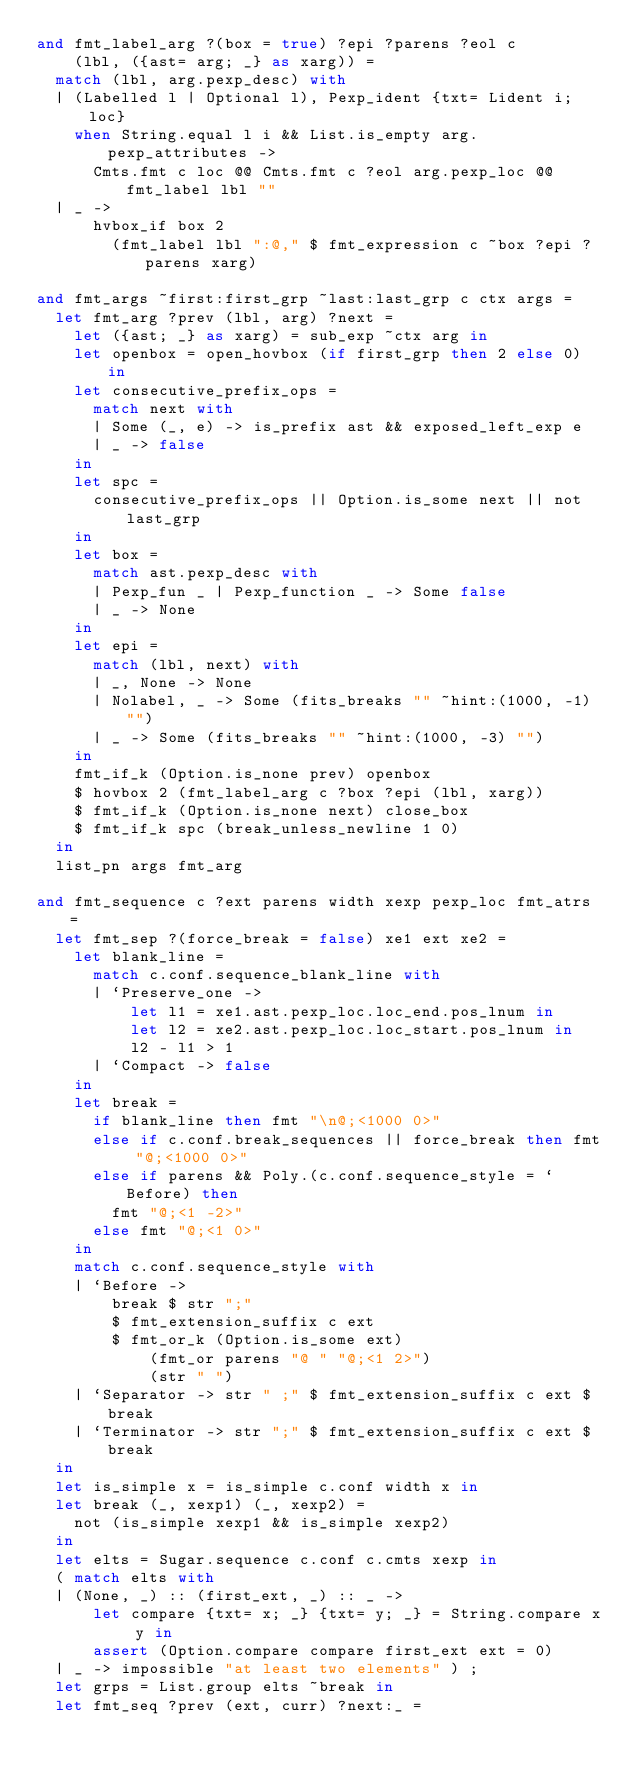<code> <loc_0><loc_0><loc_500><loc_500><_OCaml_>and fmt_label_arg ?(box = true) ?epi ?parens ?eol c
    (lbl, ({ast= arg; _} as xarg)) =
  match (lbl, arg.pexp_desc) with
  | (Labelled l | Optional l), Pexp_ident {txt= Lident i; loc}
    when String.equal l i && List.is_empty arg.pexp_attributes ->
      Cmts.fmt c loc @@ Cmts.fmt c ?eol arg.pexp_loc @@ fmt_label lbl ""
  | _ ->
      hvbox_if box 2
        (fmt_label lbl ":@," $ fmt_expression c ~box ?epi ?parens xarg)

and fmt_args ~first:first_grp ~last:last_grp c ctx args =
  let fmt_arg ?prev (lbl, arg) ?next =
    let ({ast; _} as xarg) = sub_exp ~ctx arg in
    let openbox = open_hovbox (if first_grp then 2 else 0) in
    let consecutive_prefix_ops =
      match next with
      | Some (_, e) -> is_prefix ast && exposed_left_exp e
      | _ -> false
    in
    let spc =
      consecutive_prefix_ops || Option.is_some next || not last_grp
    in
    let box =
      match ast.pexp_desc with
      | Pexp_fun _ | Pexp_function _ -> Some false
      | _ -> None
    in
    let epi =
      match (lbl, next) with
      | _, None -> None
      | Nolabel, _ -> Some (fits_breaks "" ~hint:(1000, -1) "")
      | _ -> Some (fits_breaks "" ~hint:(1000, -3) "")
    in
    fmt_if_k (Option.is_none prev) openbox
    $ hovbox 2 (fmt_label_arg c ?box ?epi (lbl, xarg))
    $ fmt_if_k (Option.is_none next) close_box
    $ fmt_if_k spc (break_unless_newline 1 0)
  in
  list_pn args fmt_arg

and fmt_sequence c ?ext parens width xexp pexp_loc fmt_atrs =
  let fmt_sep ?(force_break = false) xe1 ext xe2 =
    let blank_line =
      match c.conf.sequence_blank_line with
      | `Preserve_one ->
          let l1 = xe1.ast.pexp_loc.loc_end.pos_lnum in
          let l2 = xe2.ast.pexp_loc.loc_start.pos_lnum in
          l2 - l1 > 1
      | `Compact -> false
    in
    let break =
      if blank_line then fmt "\n@;<1000 0>"
      else if c.conf.break_sequences || force_break then fmt "@;<1000 0>"
      else if parens && Poly.(c.conf.sequence_style = `Before) then
        fmt "@;<1 -2>"
      else fmt "@;<1 0>"
    in
    match c.conf.sequence_style with
    | `Before ->
        break $ str ";"
        $ fmt_extension_suffix c ext
        $ fmt_or_k (Option.is_some ext)
            (fmt_or parens "@ " "@;<1 2>")
            (str " ")
    | `Separator -> str " ;" $ fmt_extension_suffix c ext $ break
    | `Terminator -> str ";" $ fmt_extension_suffix c ext $ break
  in
  let is_simple x = is_simple c.conf width x in
  let break (_, xexp1) (_, xexp2) =
    not (is_simple xexp1 && is_simple xexp2)
  in
  let elts = Sugar.sequence c.conf c.cmts xexp in
  ( match elts with
  | (None, _) :: (first_ext, _) :: _ ->
      let compare {txt= x; _} {txt= y; _} = String.compare x y in
      assert (Option.compare compare first_ext ext = 0)
  | _ -> impossible "at least two elements" ) ;
  let grps = List.group elts ~break in
  let fmt_seq ?prev (ext, curr) ?next:_ =</code> 